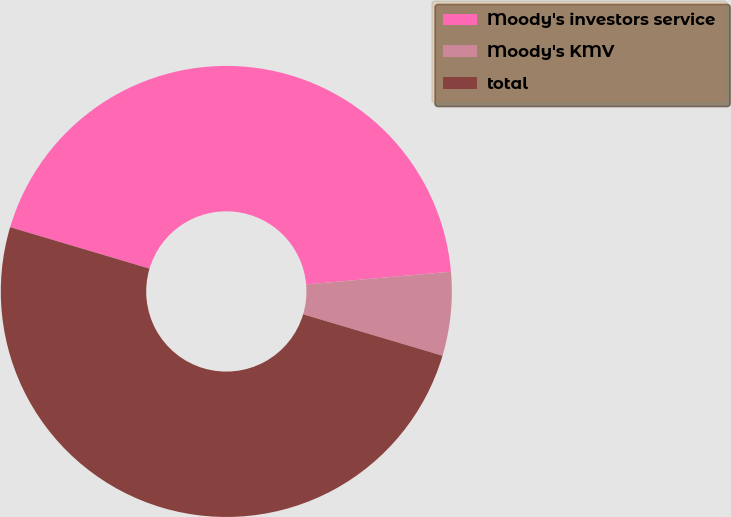Convert chart to OTSL. <chart><loc_0><loc_0><loc_500><loc_500><pie_chart><fcel>Moody's investors service<fcel>Moody's KMV<fcel>total<nl><fcel>44.01%<fcel>5.99%<fcel>50.0%<nl></chart> 